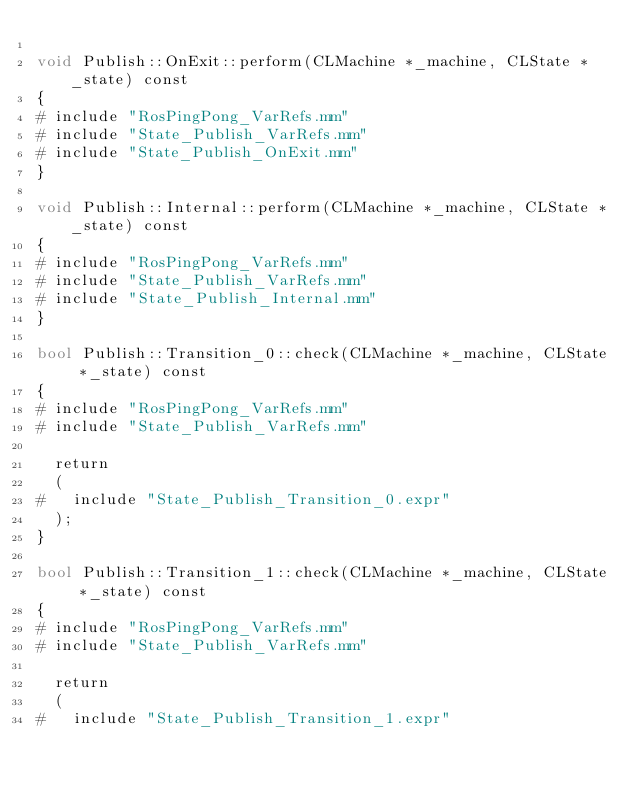Convert code to text. <code><loc_0><loc_0><loc_500><loc_500><_ObjectiveC_>
void Publish::OnExit::perform(CLMachine *_machine, CLState *_state) const
{
#	include "RosPingPong_VarRefs.mm"
#	include "State_Publish_VarRefs.mm"
#	include "State_Publish_OnExit.mm"
}

void Publish::Internal::perform(CLMachine *_machine, CLState *_state) const
{
#	include "RosPingPong_VarRefs.mm"
#	include "State_Publish_VarRefs.mm"
#	include "State_Publish_Internal.mm"
}

bool Publish::Transition_0::check(CLMachine *_machine, CLState *_state) const
{
#	include "RosPingPong_VarRefs.mm"
#	include "State_Publish_VarRefs.mm"

	return
	(
#		include "State_Publish_Transition_0.expr"
	);
}

bool Publish::Transition_1::check(CLMachine *_machine, CLState *_state) const
{
#	include "RosPingPong_VarRefs.mm"
#	include "State_Publish_VarRefs.mm"

	return
	(
#		include "State_Publish_Transition_1.expr"</code> 